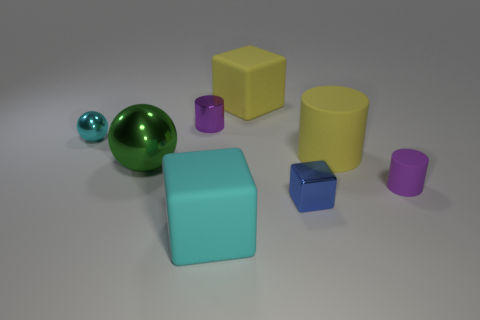There is a block that is the same color as the small sphere; what is its size?
Your answer should be very brief. Large. There is a small cylinder that is right of the blue shiny thing; is it the same color as the shiny cylinder?
Offer a very short reply. Yes. Does the green shiny ball have the same size as the blue metal cube?
Give a very brief answer. No. The tiny sphere is what color?
Provide a succinct answer. Cyan. What number of small purple cylinders have the same material as the large yellow cylinder?
Offer a terse response. 1. Are there more tiny purple objects than tiny green rubber spheres?
Offer a very short reply. Yes. How many matte cubes are behind the metal ball that is on the left side of the green metal object?
Keep it short and to the point. 1. What number of things are rubber blocks in front of the purple shiny thing or brown matte objects?
Give a very brief answer. 1. Is there a big brown thing of the same shape as the blue object?
Your answer should be compact. No. There is a large yellow matte thing that is on the right side of the yellow object that is to the left of the blue metallic block; what is its shape?
Make the answer very short. Cylinder. 